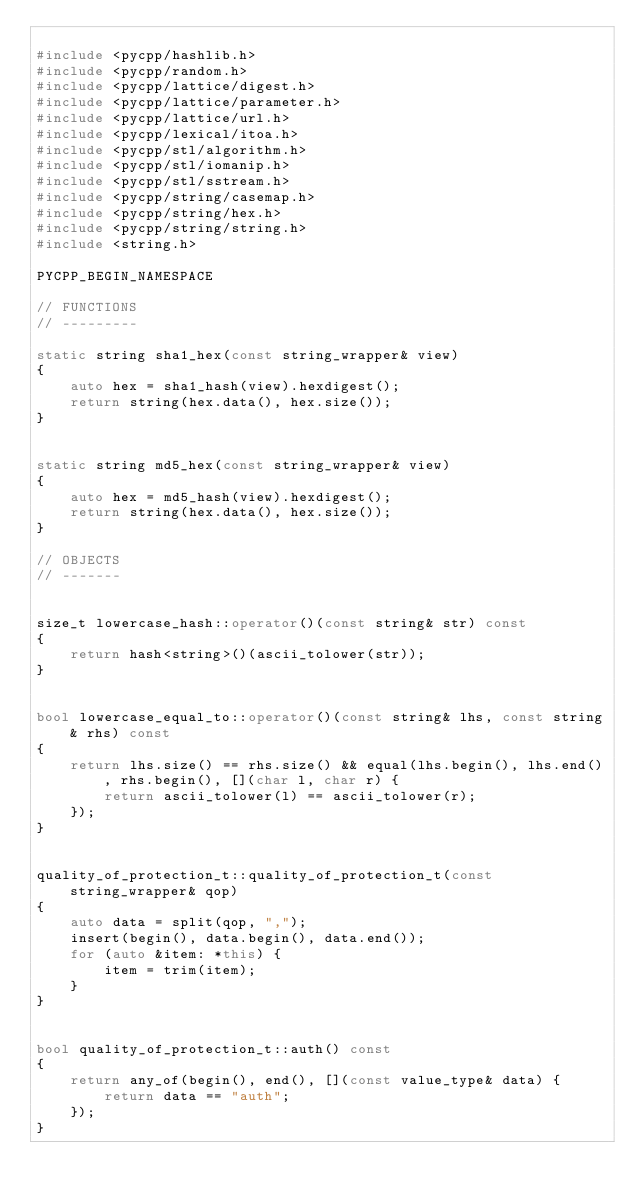Convert code to text. <code><loc_0><loc_0><loc_500><loc_500><_C++_>
#include <pycpp/hashlib.h>
#include <pycpp/random.h>
#include <pycpp/lattice/digest.h>
#include <pycpp/lattice/parameter.h>
#include <pycpp/lattice/url.h>
#include <pycpp/lexical/itoa.h>
#include <pycpp/stl/algorithm.h>
#include <pycpp/stl/iomanip.h>
#include <pycpp/stl/sstream.h>
#include <pycpp/string/casemap.h>
#include <pycpp/string/hex.h>
#include <pycpp/string/string.h>
#include <string.h>

PYCPP_BEGIN_NAMESPACE

// FUNCTIONS
// ---------

static string sha1_hex(const string_wrapper& view)
{
    auto hex = sha1_hash(view).hexdigest();
    return string(hex.data(), hex.size());
}


static string md5_hex(const string_wrapper& view)
{
    auto hex = md5_hash(view).hexdigest();
    return string(hex.data(), hex.size());
}

// OBJECTS
// -------


size_t lowercase_hash::operator()(const string& str) const
{
    return hash<string>()(ascii_tolower(str));
}


bool lowercase_equal_to::operator()(const string& lhs, const string& rhs) const
{
    return lhs.size() == rhs.size() && equal(lhs.begin(), lhs.end(), rhs.begin(), [](char l, char r) {
        return ascii_tolower(l) == ascii_tolower(r);
    });
}


quality_of_protection_t::quality_of_protection_t(const string_wrapper& qop)
{
    auto data = split(qop, ",");
    insert(begin(), data.begin(), data.end());
    for (auto &item: *this) {
        item = trim(item);
    }
}


bool quality_of_protection_t::auth() const
{
    return any_of(begin(), end(), [](const value_type& data) {
        return data == "auth";
    });
}

</code> 